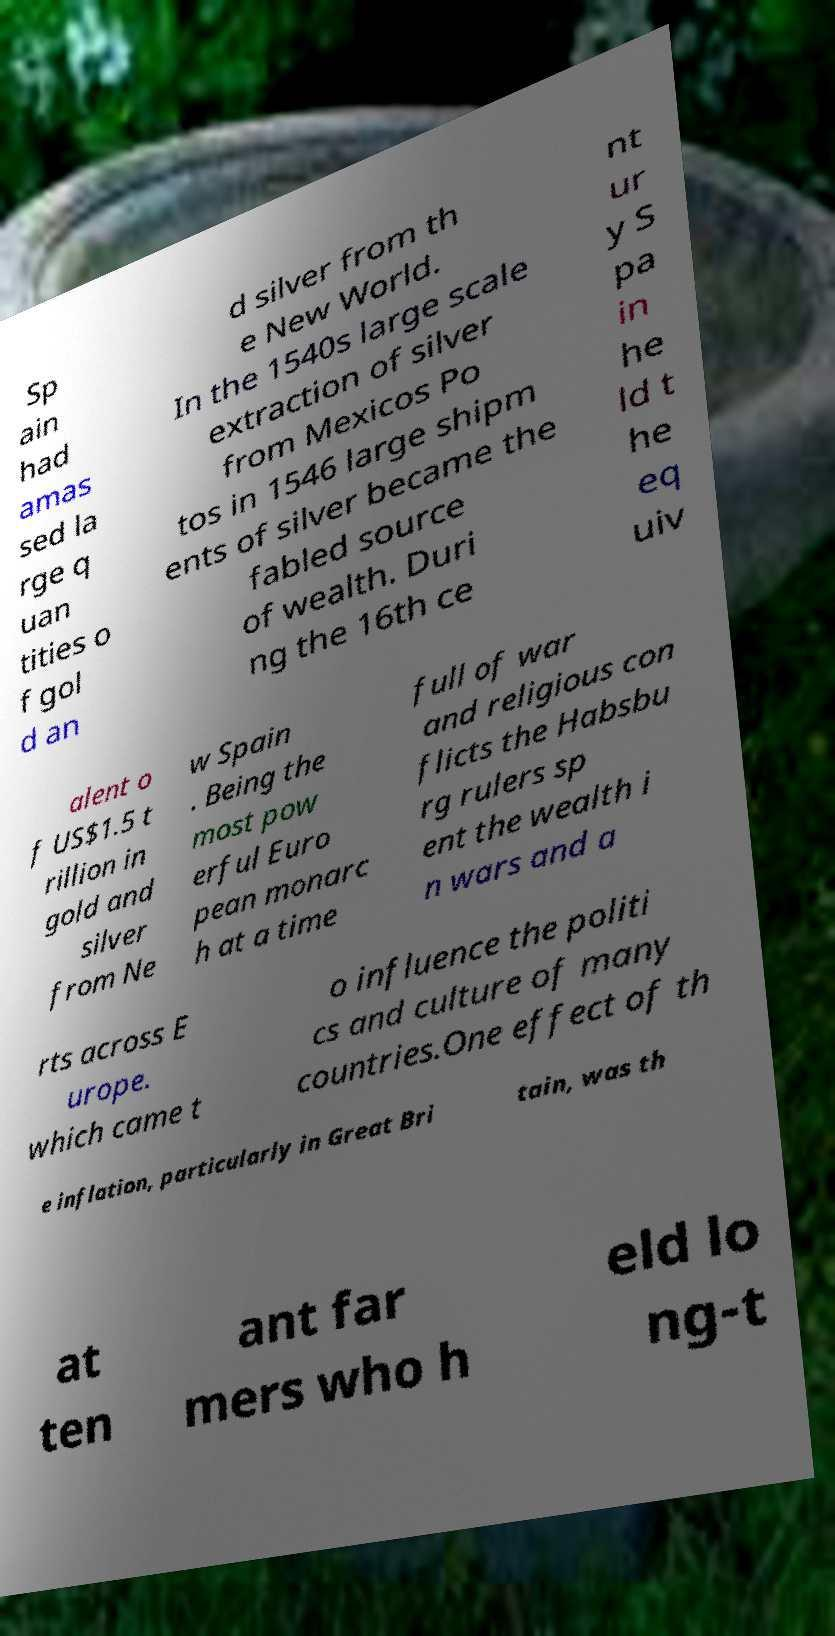There's text embedded in this image that I need extracted. Can you transcribe it verbatim? Sp ain had amas sed la rge q uan tities o f gol d an d silver from th e New World. In the 1540s large scale extraction of silver from Mexicos Po tos in 1546 large shipm ents of silver became the fabled source of wealth. Duri ng the 16th ce nt ur y S pa in he ld t he eq uiv alent o f US$1.5 t rillion in gold and silver from Ne w Spain . Being the most pow erful Euro pean monarc h at a time full of war and religious con flicts the Habsbu rg rulers sp ent the wealth i n wars and a rts across E urope. which came t o influence the politi cs and culture of many countries.One effect of th e inflation, particularly in Great Bri tain, was th at ten ant far mers who h eld lo ng-t 